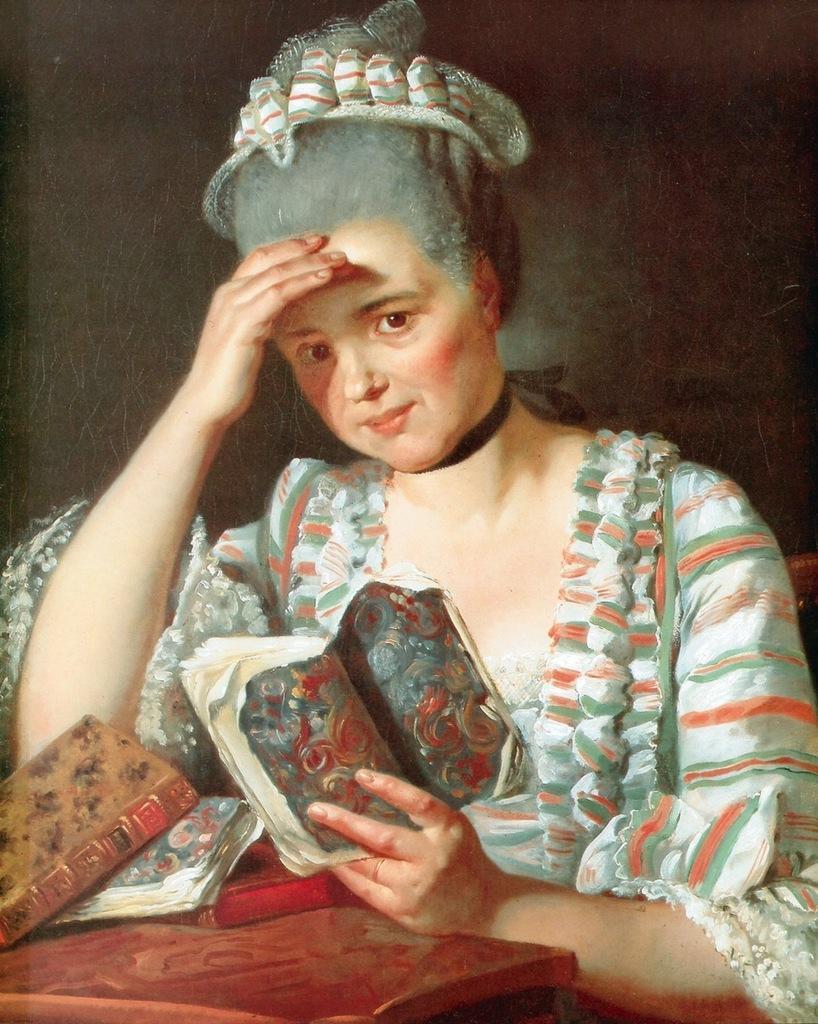Could you give a brief overview of what you see in this image? In this picture we can see a woman holding a book in her hand. There are some objects visible on the table. 